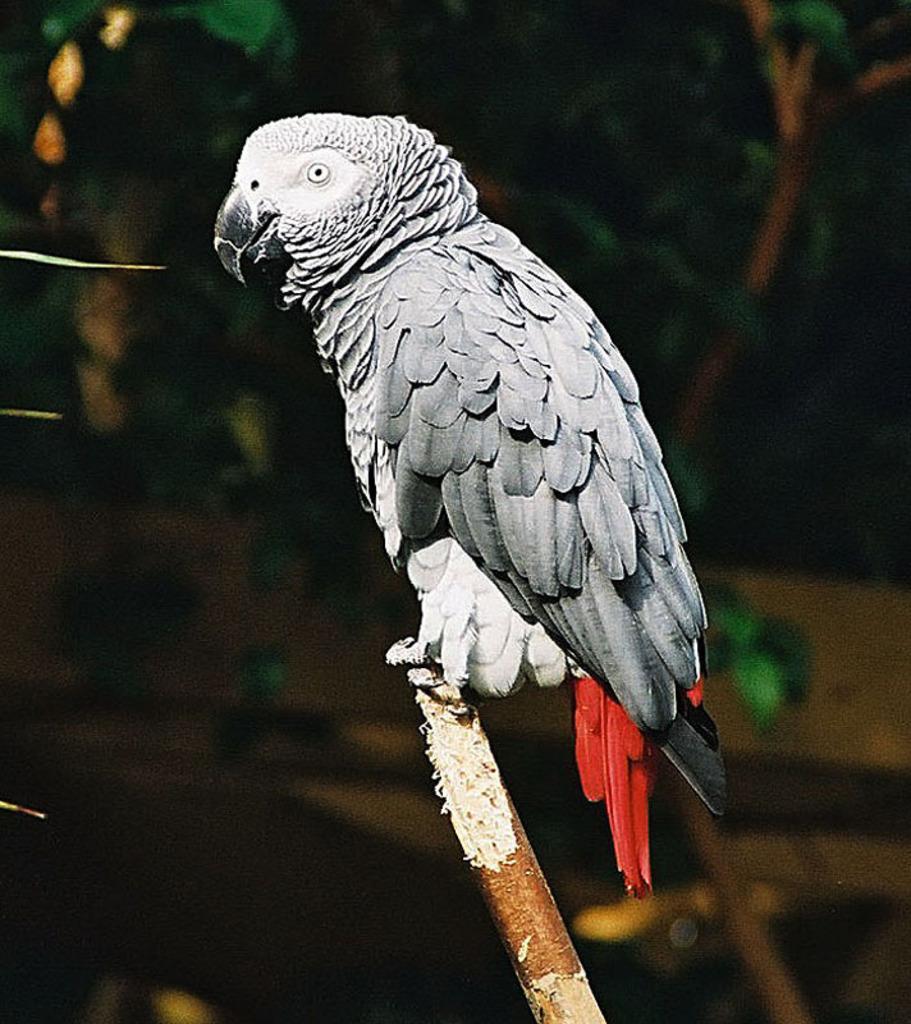Could you give a brief overview of what you see in this image? There is a grey parrot. The background is blurred. 